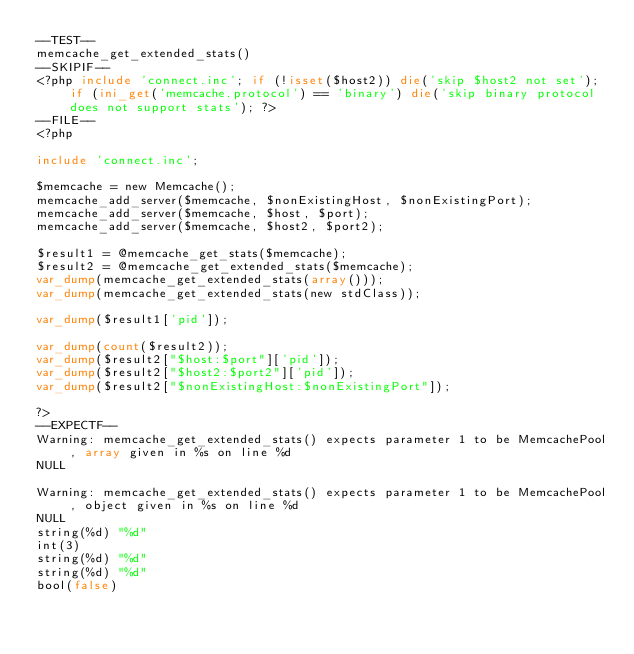Convert code to text. <code><loc_0><loc_0><loc_500><loc_500><_PHP_>--TEST--
memcache_get_extended_stats()
--SKIPIF--
<?php include 'connect.inc'; if (!isset($host2)) die('skip $host2 not set'); if (ini_get('memcache.protocol') == 'binary') die('skip binary protocol does not support stats'); ?>
--FILE--
<?php

include 'connect.inc';

$memcache = new Memcache();
memcache_add_server($memcache, $nonExistingHost, $nonExistingPort);
memcache_add_server($memcache, $host, $port);
memcache_add_server($memcache, $host2, $port2);

$result1 = @memcache_get_stats($memcache);
$result2 = @memcache_get_extended_stats($memcache);
var_dump(memcache_get_extended_stats(array()));
var_dump(memcache_get_extended_stats(new stdClass));

var_dump($result1['pid']);

var_dump(count($result2));
var_dump($result2["$host:$port"]['pid']);
var_dump($result2["$host2:$port2"]['pid']);
var_dump($result2["$nonExistingHost:$nonExistingPort"]);

?>
--EXPECTF--
Warning: memcache_get_extended_stats() expects parameter 1 to be MemcachePool, array given in %s on line %d
NULL

Warning: memcache_get_extended_stats() expects parameter 1 to be MemcachePool, object given in %s on line %d
NULL
string(%d) "%d"
int(3)
string(%d) "%d"
string(%d) "%d"
bool(false)
</code> 